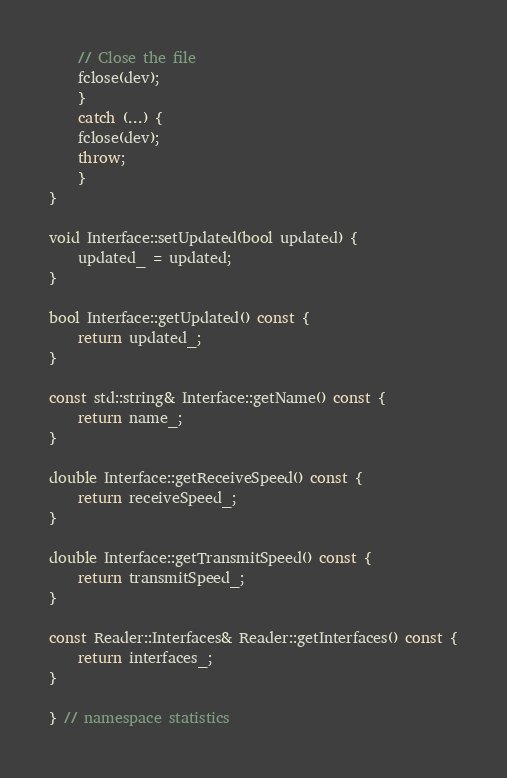Convert code to text. <code><loc_0><loc_0><loc_500><loc_500><_C++_>	// Close the file
	fclose(dev);
    }
    catch (...) {
	fclose(dev);
	throw;
    }
}

void Interface::setUpdated(bool updated) {
    updated_ = updated;
}

bool Interface::getUpdated() const {
    return updated_;
}

const std::string& Interface::getName() const {
    return name_;
}

double Interface::getReceiveSpeed() const {
    return receiveSpeed_;
}

double Interface::getTransmitSpeed() const {
    return transmitSpeed_;
}

const Reader::Interfaces& Reader::getInterfaces() const {
    return interfaces_;
}

} // namespace statistics
</code> 